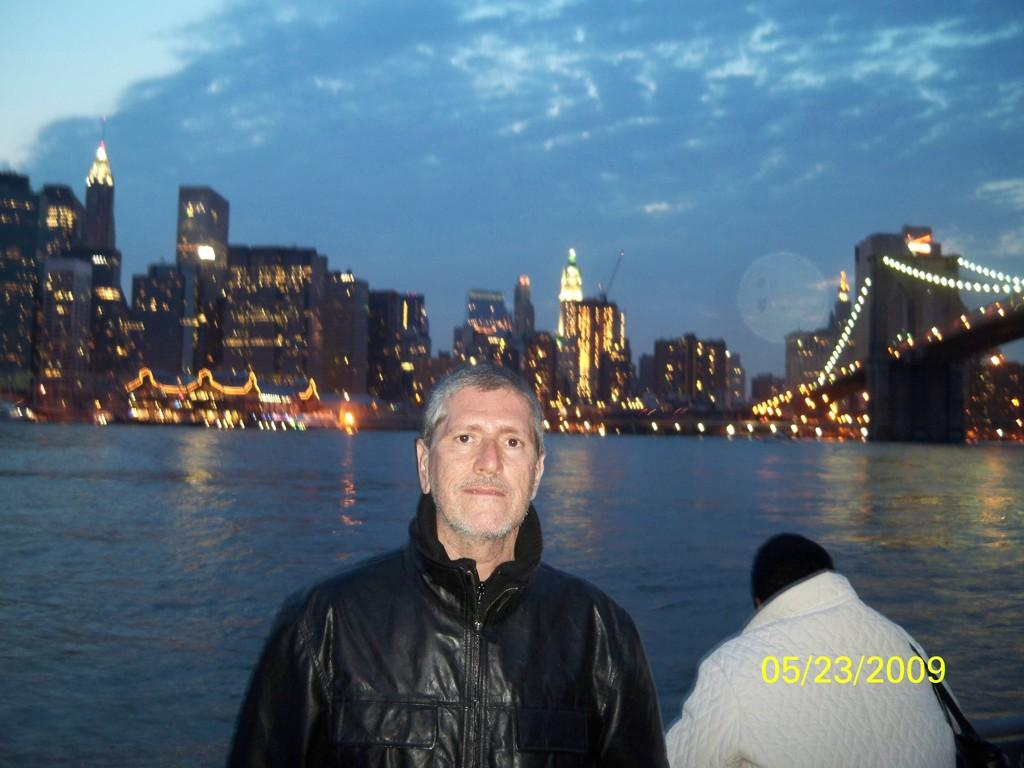How many people are in the image? There are two persons in the image. What additional information is provided on the image? The date is present on the image. What can be seen in the background of the image? There is water, buildings, decorative lights, and a bridge visible in the background. What is the condition of the sky in the image? Clouds are visible in the sky. Can you tell me how many horses are present in the image? There are no horses present in the image. Is there a laborer working on the bridge in the image? There is no laborer or any indication of work being done on the bridge in the image. 